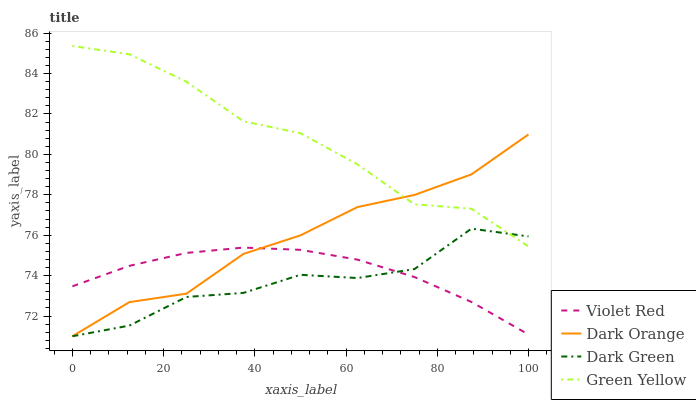Does Dark Green have the minimum area under the curve?
Answer yes or no. Yes. Does Green Yellow have the maximum area under the curve?
Answer yes or no. Yes. Does Violet Red have the minimum area under the curve?
Answer yes or no. No. Does Violet Red have the maximum area under the curve?
Answer yes or no. No. Is Violet Red the smoothest?
Answer yes or no. Yes. Is Dark Green the roughest?
Answer yes or no. Yes. Is Green Yellow the smoothest?
Answer yes or no. No. Is Green Yellow the roughest?
Answer yes or no. No. Does Dark Orange have the lowest value?
Answer yes or no. Yes. Does Violet Red have the lowest value?
Answer yes or no. No. Does Green Yellow have the highest value?
Answer yes or no. Yes. Does Violet Red have the highest value?
Answer yes or no. No. Is Violet Red less than Green Yellow?
Answer yes or no. Yes. Is Green Yellow greater than Violet Red?
Answer yes or no. Yes. Does Dark Green intersect Violet Red?
Answer yes or no. Yes. Is Dark Green less than Violet Red?
Answer yes or no. No. Is Dark Green greater than Violet Red?
Answer yes or no. No. Does Violet Red intersect Green Yellow?
Answer yes or no. No. 